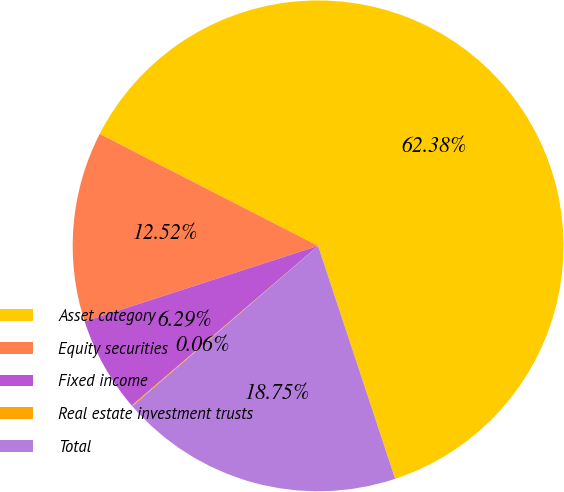Convert chart. <chart><loc_0><loc_0><loc_500><loc_500><pie_chart><fcel>Asset category<fcel>Equity securities<fcel>Fixed income<fcel>Real estate investment trusts<fcel>Total<nl><fcel>62.37%<fcel>12.52%<fcel>6.29%<fcel>0.06%<fcel>18.75%<nl></chart> 